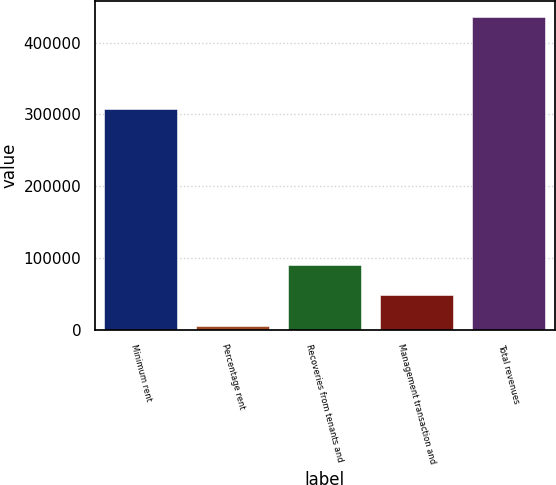<chart> <loc_0><loc_0><loc_500><loc_500><bar_chart><fcel>Minimum rent<fcel>Percentage rent<fcel>Recoveries from tenants and<fcel>Management transaction and<fcel>Total revenues<nl><fcel>308108<fcel>4655<fcel>90925.2<fcel>47790.1<fcel>436006<nl></chart> 